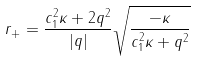Convert formula to latex. <formula><loc_0><loc_0><loc_500><loc_500>r _ { + } = \frac { c _ { 1 } ^ { 2 } \kappa + 2 q ^ { 2 } } { | q | } \sqrt { \frac { - \kappa } { c _ { 1 } ^ { 2 } \kappa + q ^ { 2 } } }</formula> 